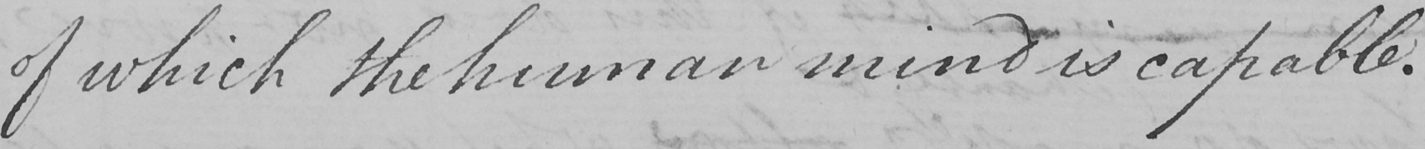Transcribe the text shown in this historical manuscript line. of which the human mind is capable . 